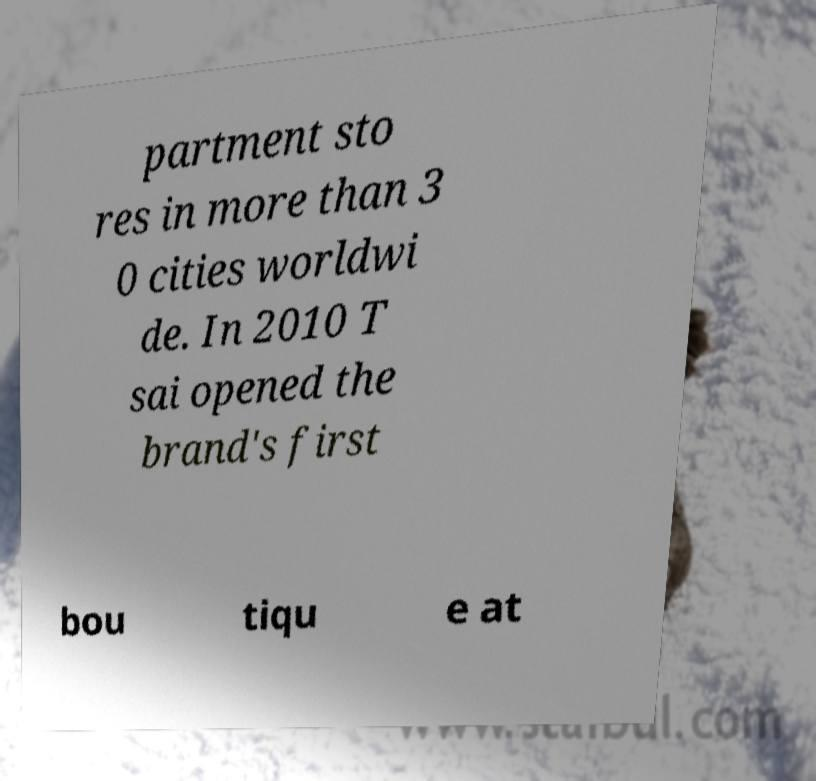There's text embedded in this image that I need extracted. Can you transcribe it verbatim? partment sto res in more than 3 0 cities worldwi de. In 2010 T sai opened the brand's first bou tiqu e at 